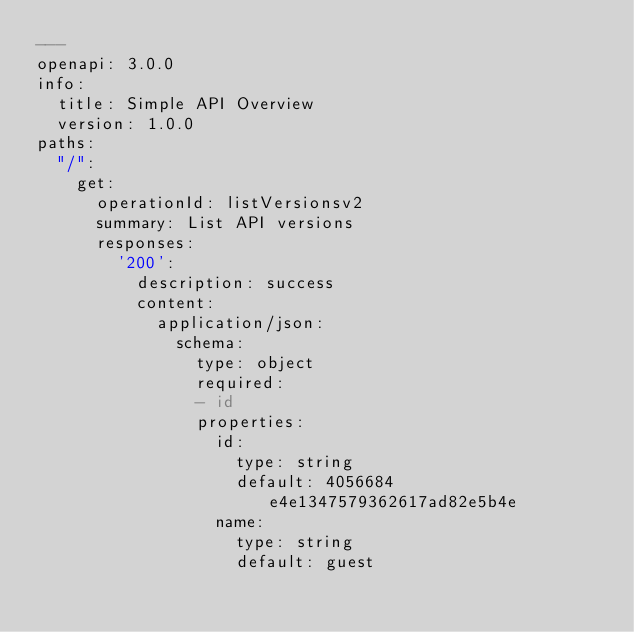<code> <loc_0><loc_0><loc_500><loc_500><_YAML_>---
openapi: 3.0.0
info:
  title: Simple API Overview
  version: 1.0.0
paths:
  "/":
    get:
      operationId: listVersionsv2
      summary: List API versions
      responses:
        '200':
          description: success
          content:
            application/json:
              schema:
                type: object
                required:
                - id
                properties:
                  id:
                    type: string
                    default: 4056684e4e1347579362617ad82e5b4e
                  name:
                    type: string
                    default: guest
</code> 